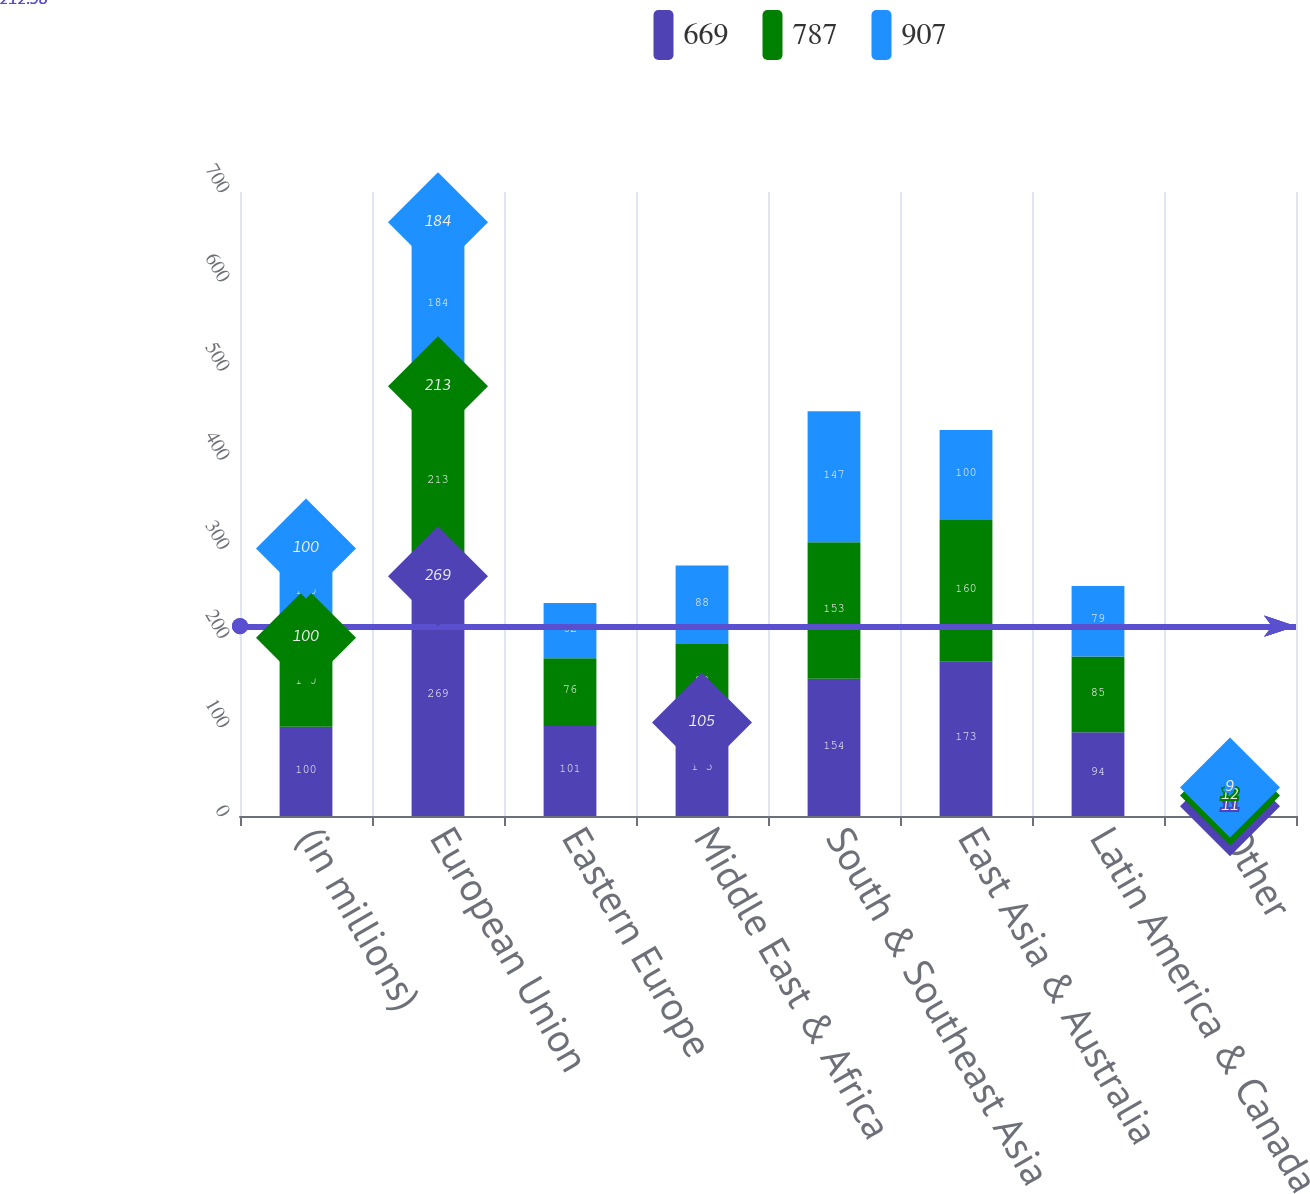Convert chart to OTSL. <chart><loc_0><loc_0><loc_500><loc_500><stacked_bar_chart><ecel><fcel>(in millions)<fcel>European Union<fcel>Eastern Europe<fcel>Middle East & Africa<fcel>South & Southeast Asia<fcel>East Asia & Australia<fcel>Latin America & Canada<fcel>Other<nl><fcel>669<fcel>100<fcel>269<fcel>101<fcel>105<fcel>154<fcel>173<fcel>94<fcel>11<nl><fcel>787<fcel>100<fcel>213<fcel>76<fcel>88<fcel>153<fcel>160<fcel>85<fcel>12<nl><fcel>907<fcel>100<fcel>184<fcel>62<fcel>88<fcel>147<fcel>100<fcel>79<fcel>9<nl></chart> 